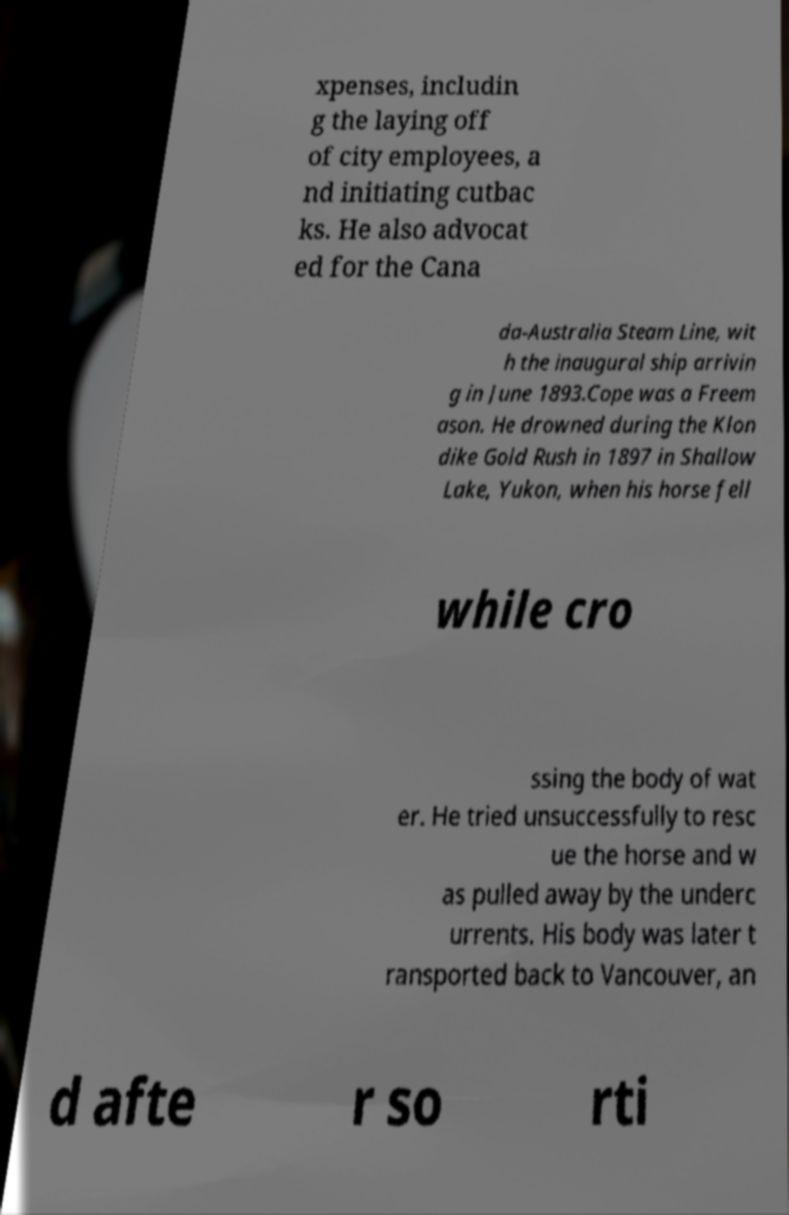Please read and relay the text visible in this image. What does it say? xpenses, includin g the laying off of city employees, a nd initiating cutbac ks. He also advocat ed for the Cana da-Australia Steam Line, wit h the inaugural ship arrivin g in June 1893.Cope was a Freem ason. He drowned during the Klon dike Gold Rush in 1897 in Shallow Lake, Yukon, when his horse fell while cro ssing the body of wat er. He tried unsuccessfully to resc ue the horse and w as pulled away by the underc urrents. His body was later t ransported back to Vancouver, an d afte r so rti 